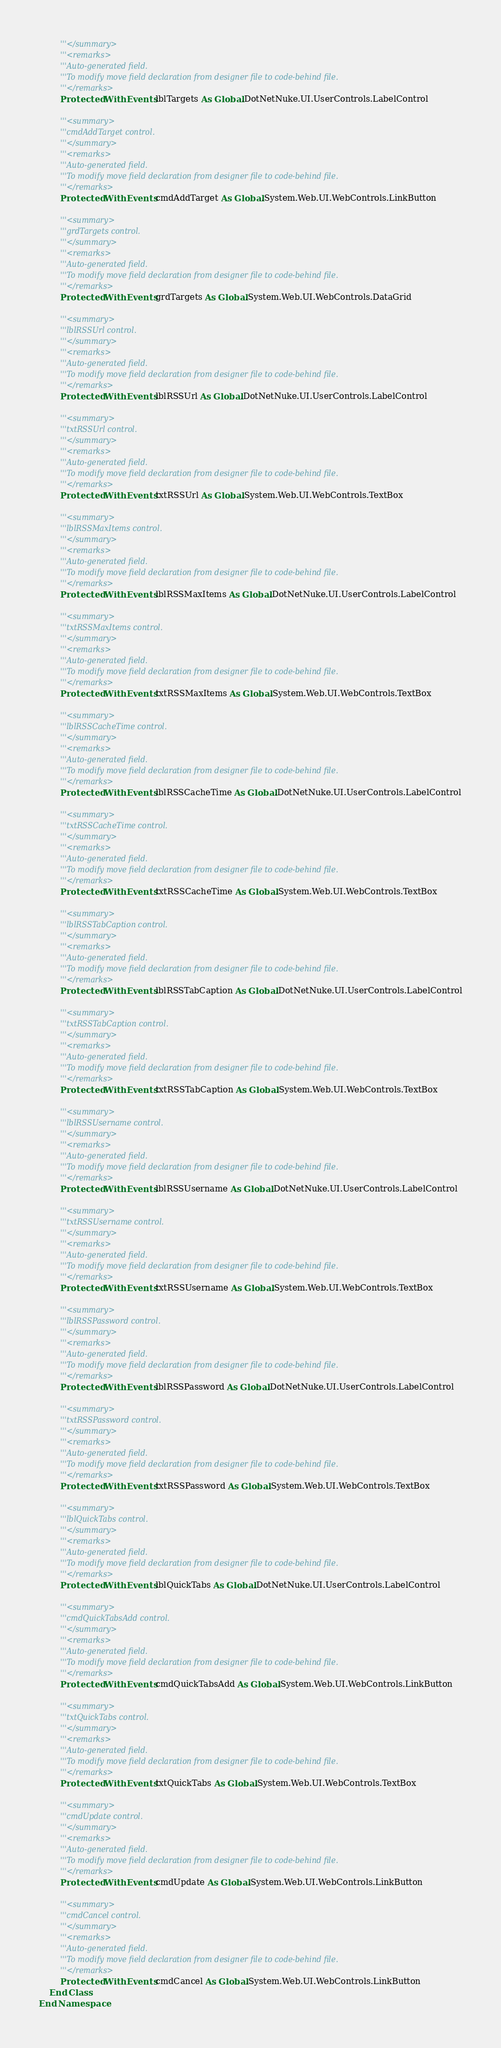<code> <loc_0><loc_0><loc_500><loc_500><_VisualBasic_>        '''</summary>
        '''<remarks>
        '''Auto-generated field.
        '''To modify move field declaration from designer file to code-behind file.
        '''</remarks>
        Protected WithEvents lblTargets As Global.DotNetNuke.UI.UserControls.LabelControl

        '''<summary>
        '''cmdAddTarget control.
        '''</summary>
        '''<remarks>
        '''Auto-generated field.
        '''To modify move field declaration from designer file to code-behind file.
        '''</remarks>
        Protected WithEvents cmdAddTarget As Global.System.Web.UI.WebControls.LinkButton

        '''<summary>
        '''grdTargets control.
        '''</summary>
        '''<remarks>
        '''Auto-generated field.
        '''To modify move field declaration from designer file to code-behind file.
        '''</remarks>
        Protected WithEvents grdTargets As Global.System.Web.UI.WebControls.DataGrid

        '''<summary>
        '''lblRSSUrl control.
        '''</summary>
        '''<remarks>
        '''Auto-generated field.
        '''To modify move field declaration from designer file to code-behind file.
        '''</remarks>
        Protected WithEvents lblRSSUrl As Global.DotNetNuke.UI.UserControls.LabelControl

        '''<summary>
        '''txtRSSUrl control.
        '''</summary>
        '''<remarks>
        '''Auto-generated field.
        '''To modify move field declaration from designer file to code-behind file.
        '''</remarks>
        Protected WithEvents txtRSSUrl As Global.System.Web.UI.WebControls.TextBox

        '''<summary>
        '''lblRSSMaxItems control.
        '''</summary>
        '''<remarks>
        '''Auto-generated field.
        '''To modify move field declaration from designer file to code-behind file.
        '''</remarks>
        Protected WithEvents lblRSSMaxItems As Global.DotNetNuke.UI.UserControls.LabelControl

        '''<summary>
        '''txtRSSMaxItems control.
        '''</summary>
        '''<remarks>
        '''Auto-generated field.
        '''To modify move field declaration from designer file to code-behind file.
        '''</remarks>
        Protected WithEvents txtRSSMaxItems As Global.System.Web.UI.WebControls.TextBox

        '''<summary>
        '''lblRSSCacheTime control.
        '''</summary>
        '''<remarks>
        '''Auto-generated field.
        '''To modify move field declaration from designer file to code-behind file.
        '''</remarks>
        Protected WithEvents lblRSSCacheTime As Global.DotNetNuke.UI.UserControls.LabelControl

        '''<summary>
        '''txtRSSCacheTime control.
        '''</summary>
        '''<remarks>
        '''Auto-generated field.
        '''To modify move field declaration from designer file to code-behind file.
        '''</remarks>
        Protected WithEvents txtRSSCacheTime As Global.System.Web.UI.WebControls.TextBox

        '''<summary>
        '''lblRSSTabCaption control.
        '''</summary>
        '''<remarks>
        '''Auto-generated field.
        '''To modify move field declaration from designer file to code-behind file.
        '''</remarks>
        Protected WithEvents lblRSSTabCaption As Global.DotNetNuke.UI.UserControls.LabelControl

        '''<summary>
        '''txtRSSTabCaption control.
        '''</summary>
        '''<remarks>
        '''Auto-generated field.
        '''To modify move field declaration from designer file to code-behind file.
        '''</remarks>
        Protected WithEvents txtRSSTabCaption As Global.System.Web.UI.WebControls.TextBox

        '''<summary>
        '''lblRSSUsername control.
        '''</summary>
        '''<remarks>
        '''Auto-generated field.
        '''To modify move field declaration from designer file to code-behind file.
        '''</remarks>
        Protected WithEvents lblRSSUsername As Global.DotNetNuke.UI.UserControls.LabelControl

        '''<summary>
        '''txtRSSUsername control.
        '''</summary>
        '''<remarks>
        '''Auto-generated field.
        '''To modify move field declaration from designer file to code-behind file.
        '''</remarks>
        Protected WithEvents txtRSSUsername As Global.System.Web.UI.WebControls.TextBox

        '''<summary>
        '''lblRSSPassword control.
        '''</summary>
        '''<remarks>
        '''Auto-generated field.
        '''To modify move field declaration from designer file to code-behind file.
        '''</remarks>
        Protected WithEvents lblRSSPassword As Global.DotNetNuke.UI.UserControls.LabelControl

        '''<summary>
        '''txtRSSPassword control.
        '''</summary>
        '''<remarks>
        '''Auto-generated field.
        '''To modify move field declaration from designer file to code-behind file.
        '''</remarks>
        Protected WithEvents txtRSSPassword As Global.System.Web.UI.WebControls.TextBox

        '''<summary>
        '''lblQuickTabs control.
        '''</summary>
        '''<remarks>
        '''Auto-generated field.
        '''To modify move field declaration from designer file to code-behind file.
        '''</remarks>
        Protected WithEvents lblQuickTabs As Global.DotNetNuke.UI.UserControls.LabelControl

        '''<summary>
        '''cmdQuickTabsAdd control.
        '''</summary>
        '''<remarks>
        '''Auto-generated field.
        '''To modify move field declaration from designer file to code-behind file.
        '''</remarks>
        Protected WithEvents cmdQuickTabsAdd As Global.System.Web.UI.WebControls.LinkButton

        '''<summary>
        '''txtQuickTabs control.
        '''</summary>
        '''<remarks>
        '''Auto-generated field.
        '''To modify move field declaration from designer file to code-behind file.
        '''</remarks>
        Protected WithEvents txtQuickTabs As Global.System.Web.UI.WebControls.TextBox

        '''<summary>
        '''cmdUpdate control.
        '''</summary>
        '''<remarks>
        '''Auto-generated field.
        '''To modify move field declaration from designer file to code-behind file.
        '''</remarks>
        Protected WithEvents cmdUpdate As Global.System.Web.UI.WebControls.LinkButton

        '''<summary>
        '''cmdCancel control.
        '''</summary>
        '''<remarks>
        '''Auto-generated field.
        '''To modify move field declaration from designer file to code-behind file.
        '''</remarks>
        Protected WithEvents cmdCancel As Global.System.Web.UI.WebControls.LinkButton
    End Class
End Namespace
</code> 